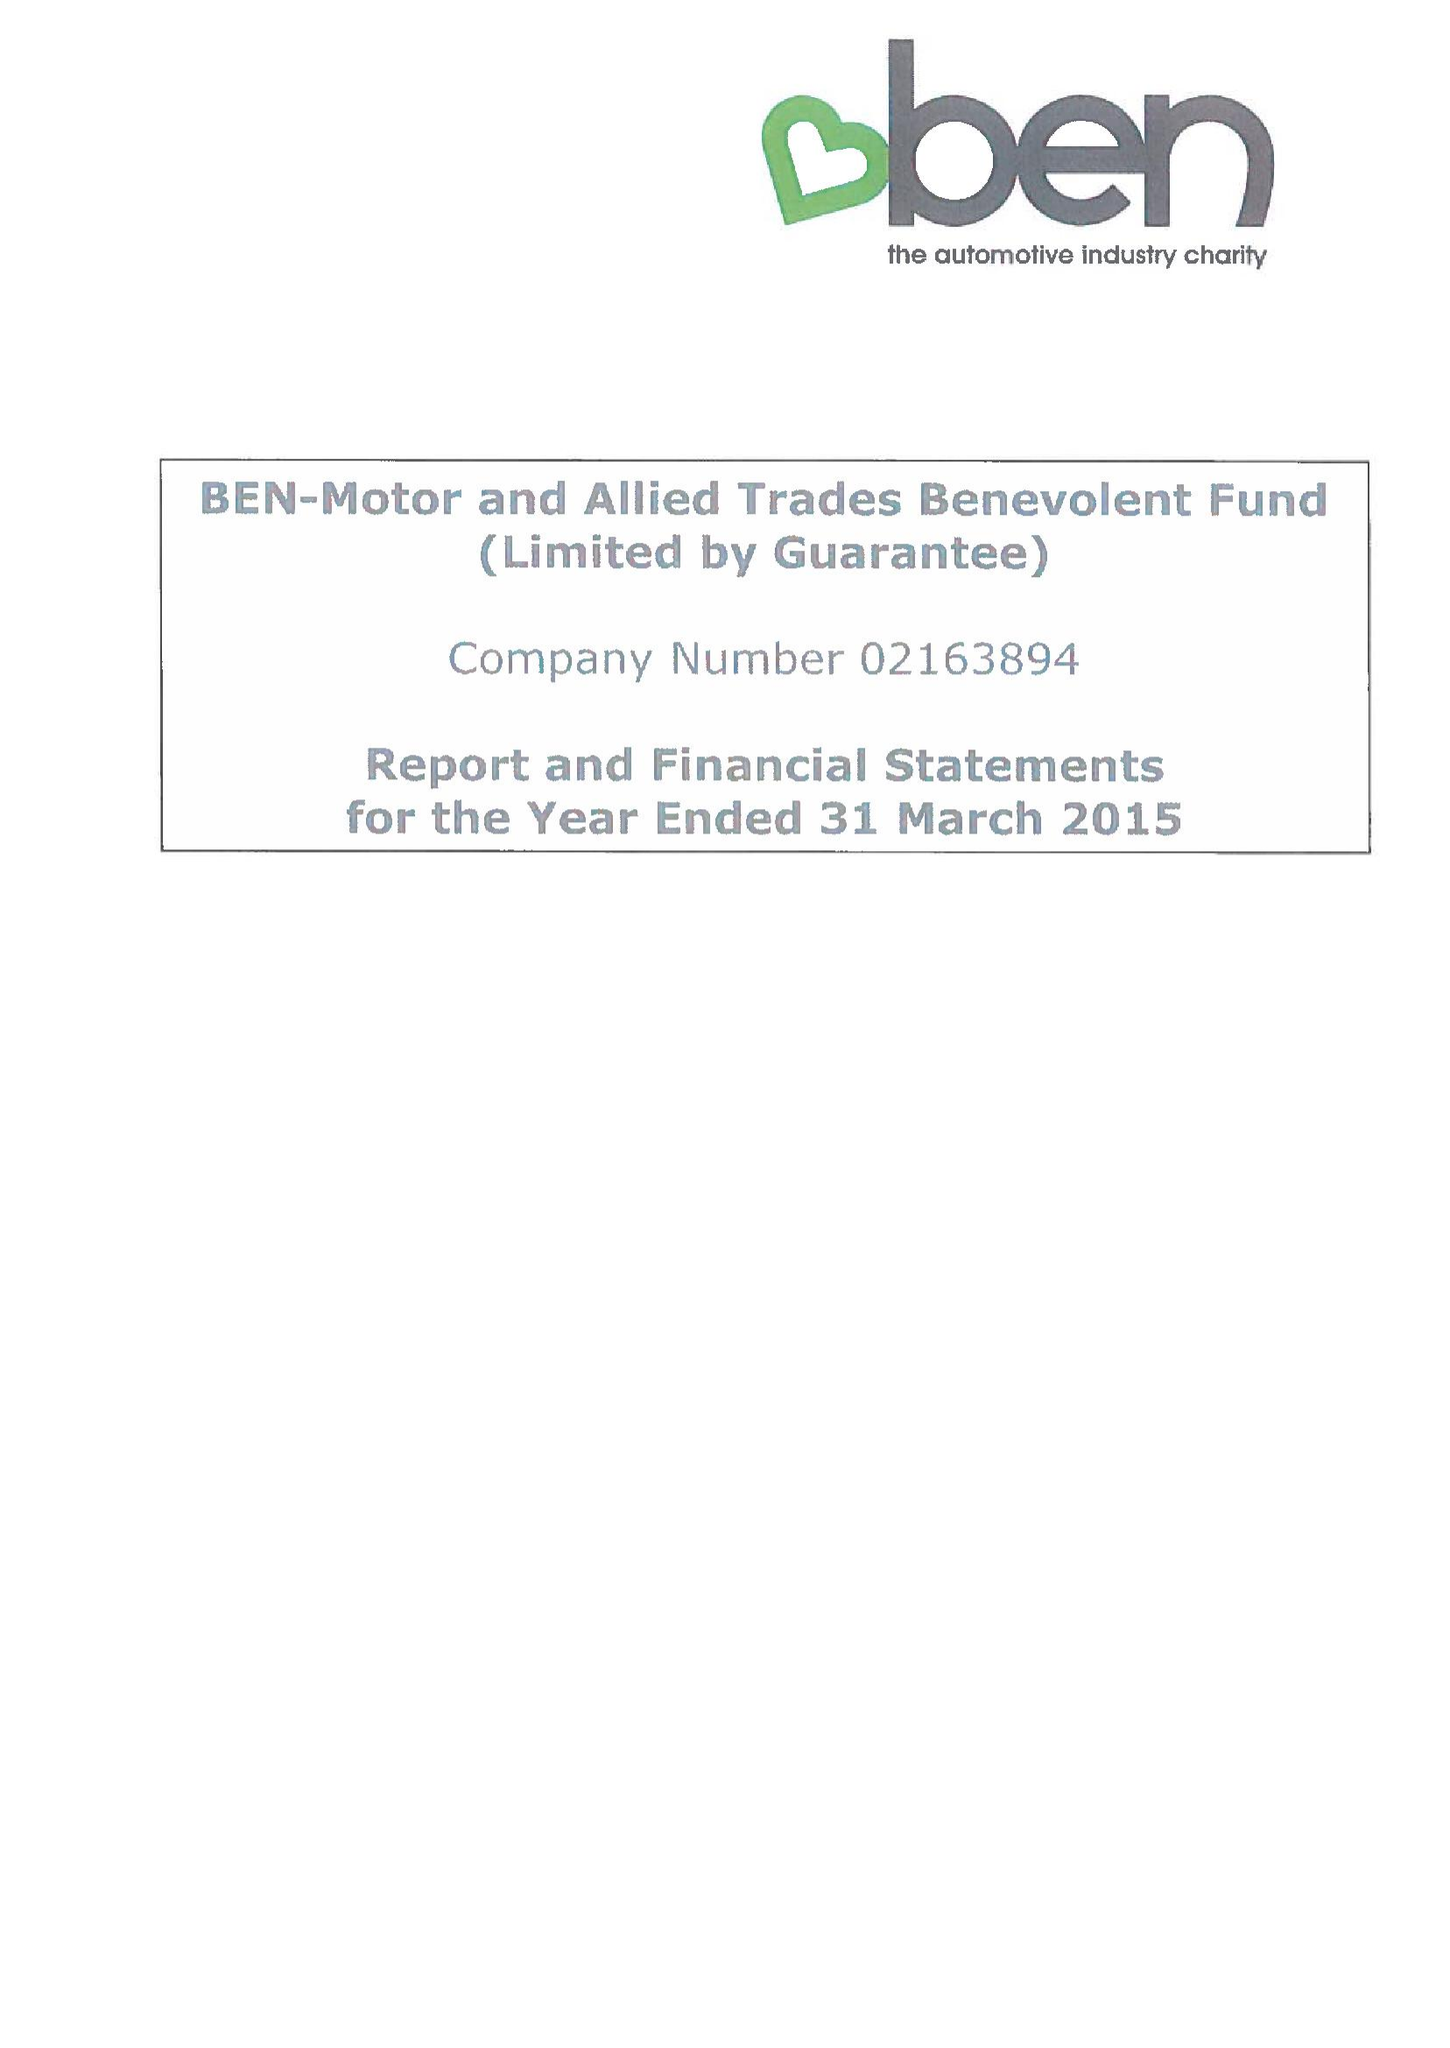What is the value for the spending_annually_in_british_pounds?
Answer the question using a single word or phrase. 12615512.00 